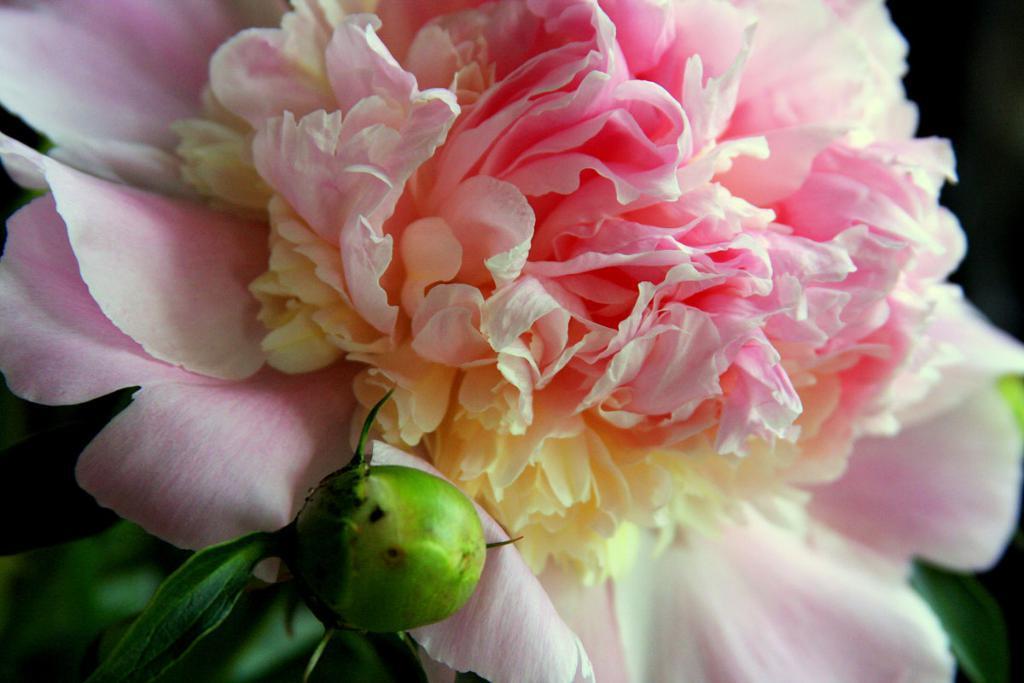Please provide a concise description of this image. This image consists of flower in pink color. At the bottom, there is a leaf in green color. 